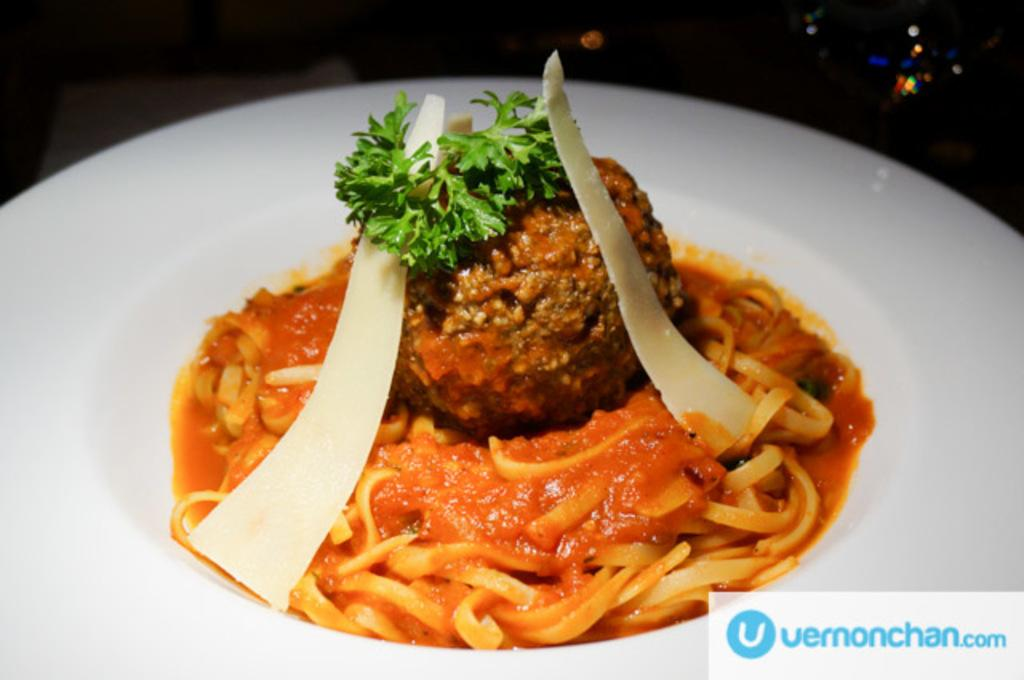What type of food can be seen in the image? The image contains food, but the specific type cannot be determined from the provided facts. What colors are present in the food? The food is in orange, brown, green, and white colors. What color is the plate that holds the food? The plate is white. How is the hose used for distributing the food in the image? There is no hose present in the image, so it cannot be used for distributing the food. 